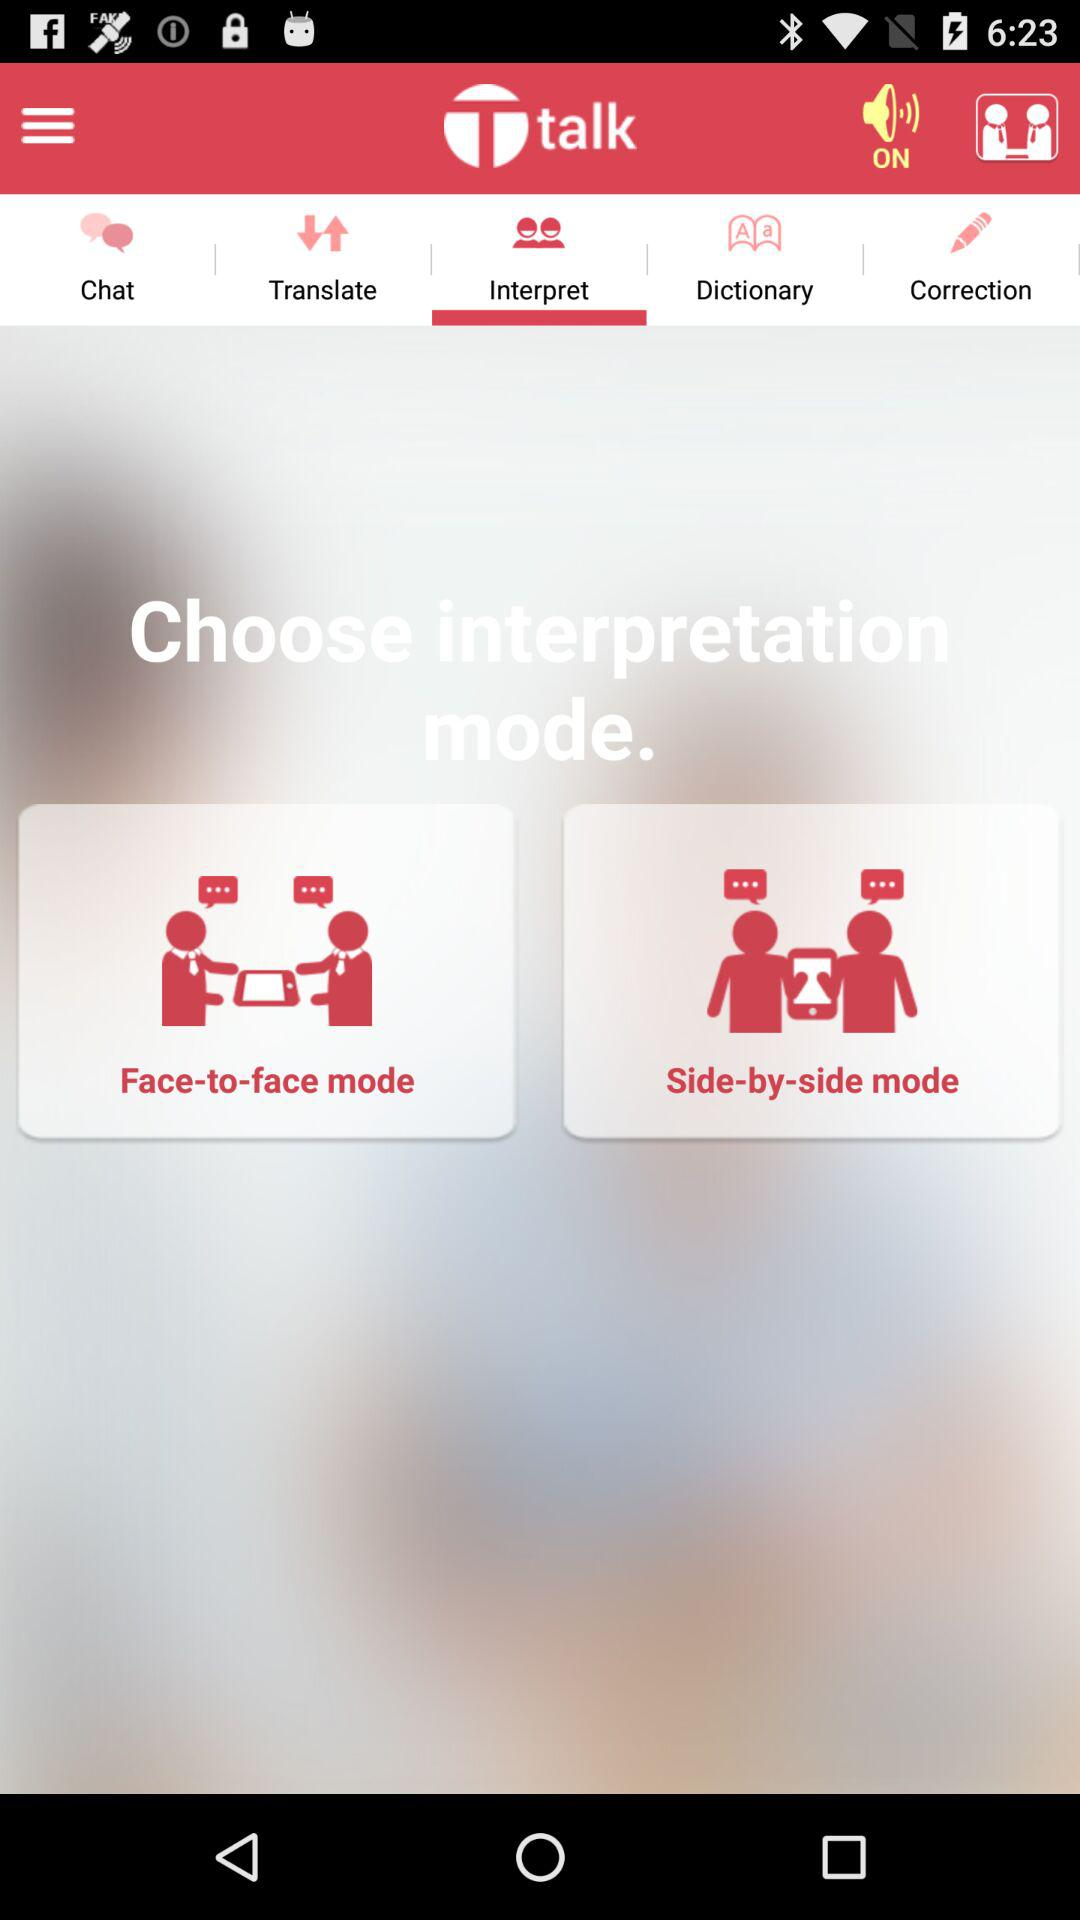Which tab am I using? You are using the "Interpret" tab. 